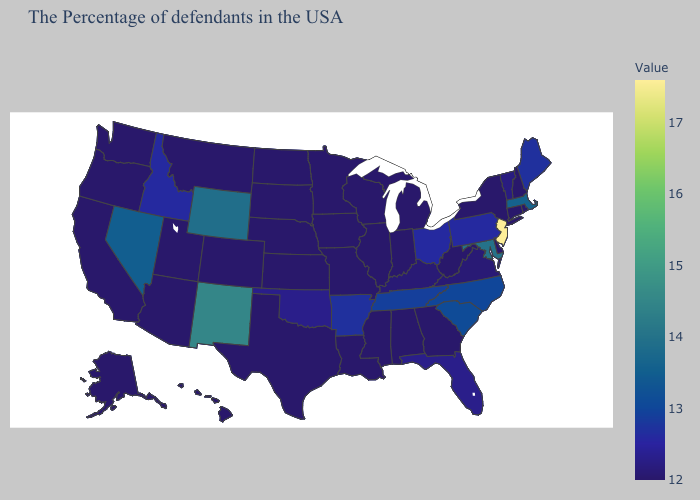Among the states that border Indiana , which have the highest value?
Keep it brief. Ohio. Is the legend a continuous bar?
Be succinct. Yes. Which states hav the highest value in the West?
Keep it brief. New Mexico. Which states hav the highest value in the MidWest?
Write a very short answer. Ohio. Does Connecticut have a lower value than Arkansas?
Give a very brief answer. Yes. Which states have the lowest value in the USA?
Concise answer only. Rhode Island, New Hampshire, Connecticut, New York, Delaware, West Virginia, Georgia, Michigan, Indiana, Alabama, Wisconsin, Illinois, Mississippi, Louisiana, Missouri, Minnesota, Iowa, Kansas, Nebraska, Texas, South Dakota, North Dakota, Colorado, Utah, Montana, Arizona, California, Washington, Oregon, Alaska, Hawaii. 